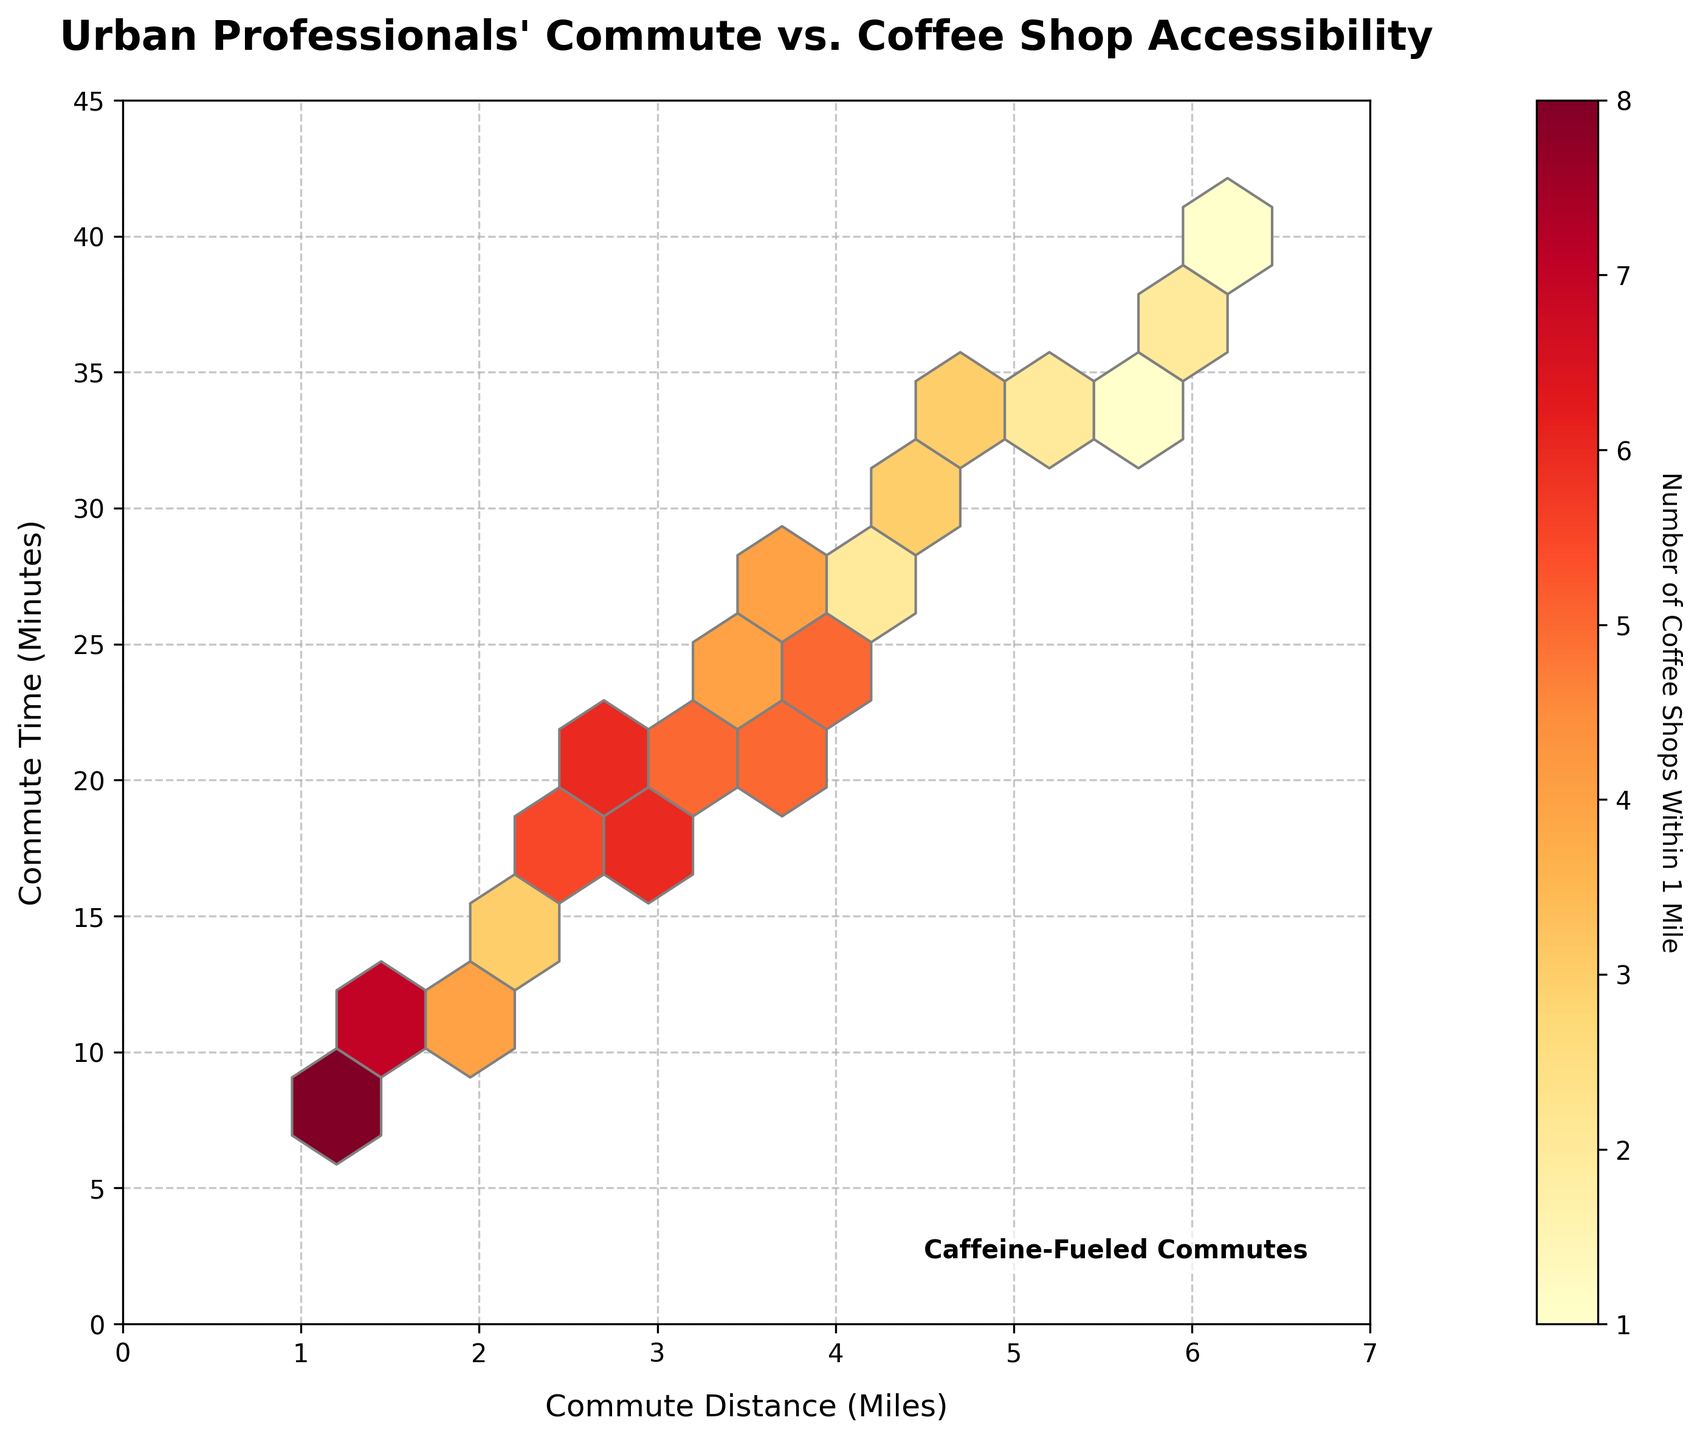What is the title of the plot? The title is typically found at the top of the plot. In this case, the title explicitly states "Urban Professionals' Commute vs. Coffee Shop Accessibility".
Answer: Urban Professionals' Commute vs. Coffee Shop Accessibility What do the axes represent? The labels on the axes explain their respective meanings. The x-axis label is "Commute Distance (Miles)", and the y-axis label is "Commute Time (Minutes)".
Answer: Commute Distance (Miles) and Commute Time (Minutes) What is the color of the hexagons indicating? The color bar on the right side of the plot indicates the relation between color and the number of coffee shops within 1 mile. The label reads "Number of Coffee Shops Within 1 Mile".
Answer: Number of Coffee Shops Within 1 Mile What is the gridsize used for the hexagons in the plot? The size or density of the hexagons can be referred to as gridsize. In the given code, gridsize is set to 10, which forms the hexbin structure visible in the plot. Reviewing the code states the gridsize of 10.
Answer: 10 What range does the x-axis cover? The x-axis range specifies the spread of commute distances shown in the plot. Based on the visible x-axis range in the figure, it starts at 0 miles and extends up to 7 miles.
Answer: 0 to 7 miles How many coffee shops are there in the lowest commute distance shown for any data point? To answer this, locate the point with the smallest commute distance (x-axis). Reviewing the raw data, the smallest distance is 1.2 miles which has 8 coffee shops.
Answer: 8 coffee shops Based on the plot, what is the relationship trend between Commute Distance and Commute Time? Visually analyzing the general direction of the hexagons’ positions in the plot reveals that as Commute Distance increases, Commute Time also increases. This indicates a positive relationship between them.
Answer: Positive relationship What is the maximum commut time represented in the plot? The y-axis indicates commute times, and the upper limit of the y-axis shows the maximum commute time covered in the plot, which is 40 minutes.
Answer: 40 minutes Which commute distance bins have the highest number of coffee shops nearby? Observing the hexagons, the ones with the hottest color (indicating highest numbers based on the color bar). This happens between 2 to 3 miles where the color is darker indicating 6,7, or more coffee shops.
Answer: 2 to 3 miles Between the commute times of 10 to 20 minutes, which hexagon color is prominently visible, and what does it signify? By observing the color of prominent hexagons within this range through the color bar, medium yellow-orange indicates fewer to moderate coffee shops (3-6 within 1 mile).
Answer: Yellow-orange representing 3-6 coffee shops Is there a visible overall trend between the number of coffee shops and commute time? Exploring the color gradient along the commute time axis, the trend shows a concentration of coffee shops (darker hexagons) at lower to mid-length commute times primarily around 10-25 minutes.
Answer: Higher coffee shop density for shorter commutes 